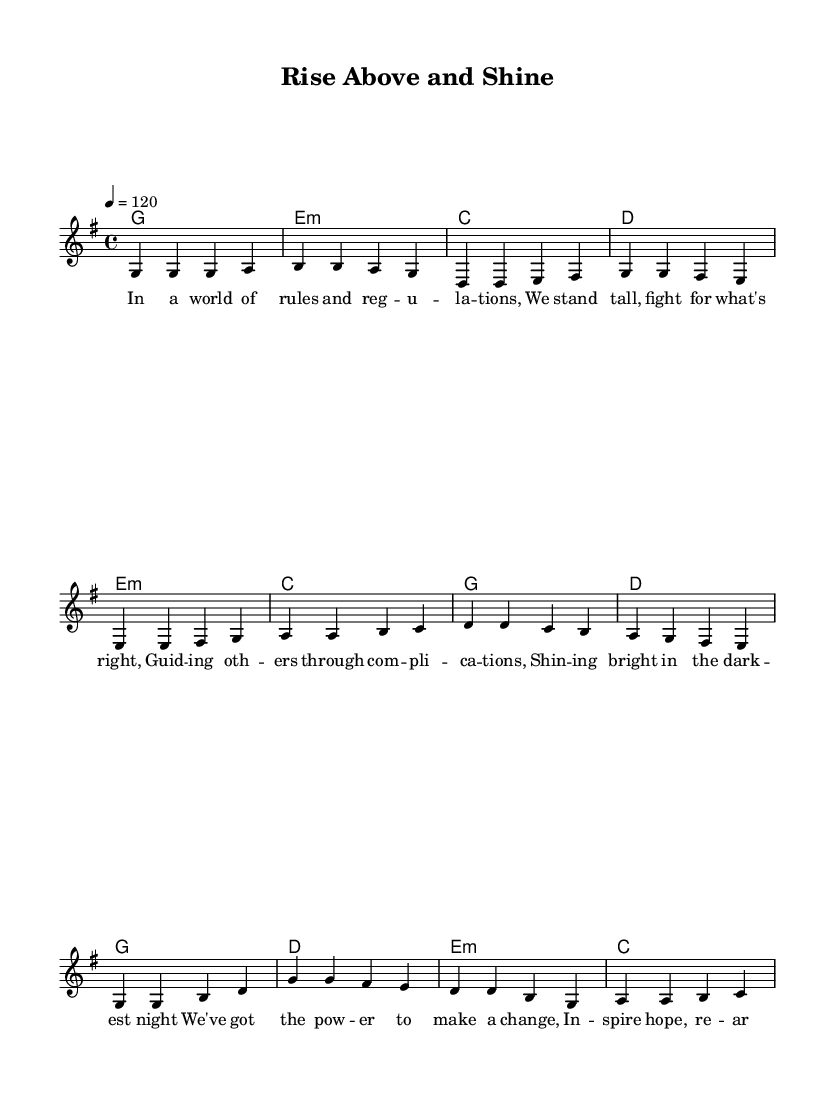What is the key signature of this music? The key signature indicated at the beginning is G major, which has one sharp (F#).
Answer: G major What is the time signature of the piece? The time signature shown at the beginning of the score is 4/4, indicating four beats per measure and a quarter note receives one beat.
Answer: 4/4 What is the tempo marking of the piece? The tempo marking in the score indicates that the piece should be played at a speed of 120 beats per minute, which is a moderate tempo.
Answer: 120 How many measures are in the verse? The verse section consists of four measures when counting the vertical bars on the staff.
Answer: 4 What is the last word of the chorus? The last word of the chorus as notated in the lyrics section is "mine," which is part of the line that concludes the lyrics of the chorus.
Answer: mine What are the first two chords of the verse? The first two chords indicated in the chord section above the verse are G major and E minor, which appear in the first two measures of the verse.
Answer: G, E minor How does the pre-chorus lyrically transition to the chorus? The pre-chorus ends with the phrase "re-arrange," leading musically and thematically into the uplifting message of the chorus about rising above challenges.
Answer: Re-arrange 